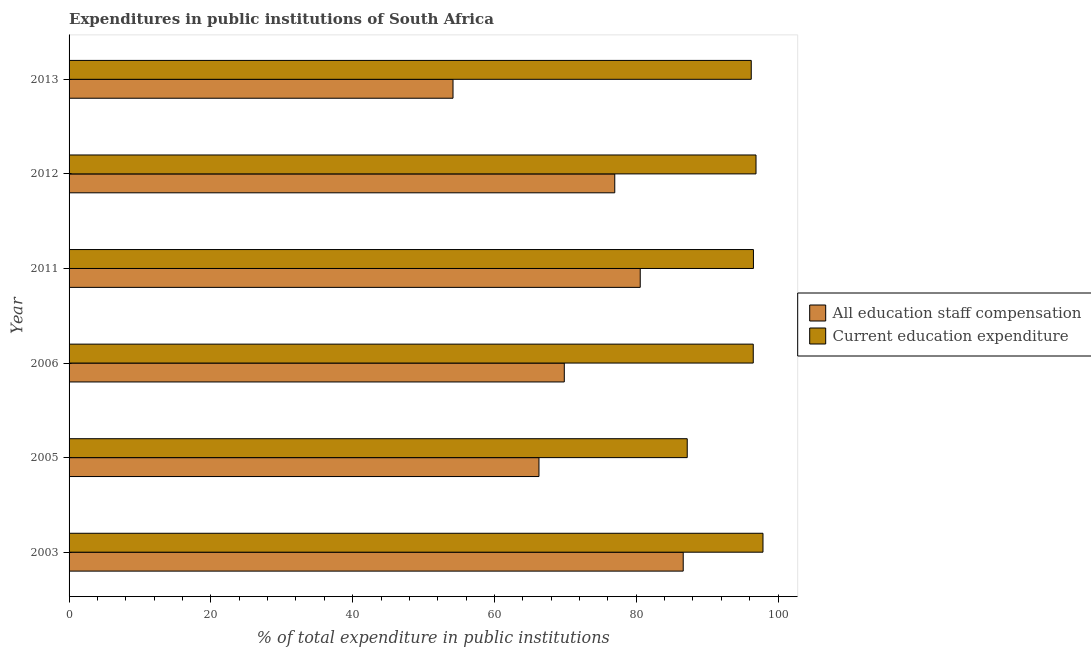How many groups of bars are there?
Ensure brevity in your answer.  6. What is the label of the 5th group of bars from the top?
Make the answer very short. 2005. In how many cases, is the number of bars for a given year not equal to the number of legend labels?
Ensure brevity in your answer.  0. What is the expenditure in staff compensation in 2012?
Ensure brevity in your answer.  76.97. Across all years, what is the maximum expenditure in education?
Offer a terse response. 97.87. Across all years, what is the minimum expenditure in staff compensation?
Provide a short and direct response. 54.15. In which year was the expenditure in staff compensation maximum?
Keep it short and to the point. 2003. In which year was the expenditure in staff compensation minimum?
Your answer should be very brief. 2013. What is the total expenditure in staff compensation in the graph?
Your answer should be compact. 434.42. What is the difference between the expenditure in staff compensation in 2005 and that in 2011?
Keep it short and to the point. -14.28. What is the difference between the expenditure in staff compensation in 2013 and the expenditure in education in 2006?
Make the answer very short. -42.35. What is the average expenditure in staff compensation per year?
Ensure brevity in your answer.  72.4. In the year 2011, what is the difference between the expenditure in education and expenditure in staff compensation?
Keep it short and to the point. 15.97. In how many years, is the expenditure in staff compensation greater than 16 %?
Keep it short and to the point. 6. What is the ratio of the expenditure in staff compensation in 2011 to that in 2012?
Give a very brief answer. 1.05. Is the expenditure in staff compensation in 2003 less than that in 2006?
Offer a very short reply. No. Is the difference between the expenditure in staff compensation in 2005 and 2012 greater than the difference between the expenditure in education in 2005 and 2012?
Provide a short and direct response. No. What is the difference between the highest and the lowest expenditure in staff compensation?
Provide a succinct answer. 32.47. In how many years, is the expenditure in education greater than the average expenditure in education taken over all years?
Keep it short and to the point. 5. Is the sum of the expenditure in education in 2005 and 2011 greater than the maximum expenditure in staff compensation across all years?
Offer a terse response. Yes. What does the 2nd bar from the top in 2006 represents?
Your answer should be compact. All education staff compensation. What does the 1st bar from the bottom in 2011 represents?
Your response must be concise. All education staff compensation. How many years are there in the graph?
Make the answer very short. 6. What is the difference between two consecutive major ticks on the X-axis?
Offer a very short reply. 20. Does the graph contain any zero values?
Your response must be concise. No. Does the graph contain grids?
Your answer should be very brief. No. Where does the legend appear in the graph?
Make the answer very short. Center right. How many legend labels are there?
Offer a very short reply. 2. How are the legend labels stacked?
Provide a succinct answer. Vertical. What is the title of the graph?
Offer a terse response. Expenditures in public institutions of South Africa. Does "Investment in Telecom" appear as one of the legend labels in the graph?
Offer a very short reply. No. What is the label or title of the X-axis?
Offer a terse response. % of total expenditure in public institutions. What is the label or title of the Y-axis?
Offer a very short reply. Year. What is the % of total expenditure in public institutions of All education staff compensation in 2003?
Provide a succinct answer. 86.62. What is the % of total expenditure in public institutions in Current education expenditure in 2003?
Ensure brevity in your answer.  97.87. What is the % of total expenditure in public institutions in All education staff compensation in 2005?
Your response must be concise. 66.28. What is the % of total expenditure in public institutions in Current education expenditure in 2005?
Ensure brevity in your answer.  87.19. What is the % of total expenditure in public institutions in All education staff compensation in 2006?
Offer a very short reply. 69.85. What is the % of total expenditure in public institutions in Current education expenditure in 2006?
Give a very brief answer. 96.5. What is the % of total expenditure in public institutions in All education staff compensation in 2011?
Give a very brief answer. 80.56. What is the % of total expenditure in public institutions in Current education expenditure in 2011?
Make the answer very short. 96.53. What is the % of total expenditure in public institutions in All education staff compensation in 2012?
Ensure brevity in your answer.  76.97. What is the % of total expenditure in public institutions in Current education expenditure in 2012?
Your answer should be very brief. 96.89. What is the % of total expenditure in public institutions of All education staff compensation in 2013?
Provide a succinct answer. 54.15. What is the % of total expenditure in public institutions in Current education expenditure in 2013?
Keep it short and to the point. 96.22. Across all years, what is the maximum % of total expenditure in public institutions in All education staff compensation?
Provide a succinct answer. 86.62. Across all years, what is the maximum % of total expenditure in public institutions in Current education expenditure?
Your response must be concise. 97.87. Across all years, what is the minimum % of total expenditure in public institutions in All education staff compensation?
Your answer should be compact. 54.15. Across all years, what is the minimum % of total expenditure in public institutions in Current education expenditure?
Your response must be concise. 87.19. What is the total % of total expenditure in public institutions of All education staff compensation in the graph?
Your answer should be very brief. 434.42. What is the total % of total expenditure in public institutions of Current education expenditure in the graph?
Offer a very short reply. 571.19. What is the difference between the % of total expenditure in public institutions in All education staff compensation in 2003 and that in 2005?
Provide a short and direct response. 20.35. What is the difference between the % of total expenditure in public institutions of Current education expenditure in 2003 and that in 2005?
Ensure brevity in your answer.  10.69. What is the difference between the % of total expenditure in public institutions of All education staff compensation in 2003 and that in 2006?
Ensure brevity in your answer.  16.77. What is the difference between the % of total expenditure in public institutions of Current education expenditure in 2003 and that in 2006?
Make the answer very short. 1.37. What is the difference between the % of total expenditure in public institutions in All education staff compensation in 2003 and that in 2011?
Provide a short and direct response. 6.06. What is the difference between the % of total expenditure in public institutions in Current education expenditure in 2003 and that in 2011?
Ensure brevity in your answer.  1.35. What is the difference between the % of total expenditure in public institutions in All education staff compensation in 2003 and that in 2012?
Give a very brief answer. 9.65. What is the difference between the % of total expenditure in public institutions of Current education expenditure in 2003 and that in 2012?
Provide a succinct answer. 0.98. What is the difference between the % of total expenditure in public institutions in All education staff compensation in 2003 and that in 2013?
Give a very brief answer. 32.47. What is the difference between the % of total expenditure in public institutions of Current education expenditure in 2003 and that in 2013?
Your answer should be very brief. 1.65. What is the difference between the % of total expenditure in public institutions in All education staff compensation in 2005 and that in 2006?
Your answer should be very brief. -3.57. What is the difference between the % of total expenditure in public institutions of Current education expenditure in 2005 and that in 2006?
Your response must be concise. -9.31. What is the difference between the % of total expenditure in public institutions of All education staff compensation in 2005 and that in 2011?
Your answer should be very brief. -14.28. What is the difference between the % of total expenditure in public institutions of Current education expenditure in 2005 and that in 2011?
Give a very brief answer. -9.34. What is the difference between the % of total expenditure in public institutions of All education staff compensation in 2005 and that in 2012?
Offer a very short reply. -10.69. What is the difference between the % of total expenditure in public institutions of Current education expenditure in 2005 and that in 2012?
Ensure brevity in your answer.  -9.7. What is the difference between the % of total expenditure in public institutions of All education staff compensation in 2005 and that in 2013?
Your answer should be compact. 12.12. What is the difference between the % of total expenditure in public institutions in Current education expenditure in 2005 and that in 2013?
Your answer should be very brief. -9.03. What is the difference between the % of total expenditure in public institutions of All education staff compensation in 2006 and that in 2011?
Keep it short and to the point. -10.71. What is the difference between the % of total expenditure in public institutions of Current education expenditure in 2006 and that in 2011?
Make the answer very short. -0.03. What is the difference between the % of total expenditure in public institutions in All education staff compensation in 2006 and that in 2012?
Your answer should be very brief. -7.12. What is the difference between the % of total expenditure in public institutions in Current education expenditure in 2006 and that in 2012?
Offer a very short reply. -0.39. What is the difference between the % of total expenditure in public institutions of All education staff compensation in 2006 and that in 2013?
Keep it short and to the point. 15.7. What is the difference between the % of total expenditure in public institutions of Current education expenditure in 2006 and that in 2013?
Offer a very short reply. 0.28. What is the difference between the % of total expenditure in public institutions of All education staff compensation in 2011 and that in 2012?
Provide a succinct answer. 3.59. What is the difference between the % of total expenditure in public institutions in Current education expenditure in 2011 and that in 2012?
Give a very brief answer. -0.36. What is the difference between the % of total expenditure in public institutions in All education staff compensation in 2011 and that in 2013?
Your response must be concise. 26.41. What is the difference between the % of total expenditure in public institutions in Current education expenditure in 2011 and that in 2013?
Provide a short and direct response. 0.31. What is the difference between the % of total expenditure in public institutions in All education staff compensation in 2012 and that in 2013?
Keep it short and to the point. 22.81. What is the difference between the % of total expenditure in public institutions of Current education expenditure in 2012 and that in 2013?
Offer a terse response. 0.67. What is the difference between the % of total expenditure in public institutions in All education staff compensation in 2003 and the % of total expenditure in public institutions in Current education expenditure in 2005?
Keep it short and to the point. -0.57. What is the difference between the % of total expenditure in public institutions of All education staff compensation in 2003 and the % of total expenditure in public institutions of Current education expenditure in 2006?
Your answer should be very brief. -9.88. What is the difference between the % of total expenditure in public institutions of All education staff compensation in 2003 and the % of total expenditure in public institutions of Current education expenditure in 2011?
Make the answer very short. -9.9. What is the difference between the % of total expenditure in public institutions in All education staff compensation in 2003 and the % of total expenditure in public institutions in Current education expenditure in 2012?
Make the answer very short. -10.27. What is the difference between the % of total expenditure in public institutions of All education staff compensation in 2003 and the % of total expenditure in public institutions of Current education expenditure in 2013?
Provide a succinct answer. -9.6. What is the difference between the % of total expenditure in public institutions in All education staff compensation in 2005 and the % of total expenditure in public institutions in Current education expenditure in 2006?
Your response must be concise. -30.22. What is the difference between the % of total expenditure in public institutions of All education staff compensation in 2005 and the % of total expenditure in public institutions of Current education expenditure in 2011?
Your answer should be very brief. -30.25. What is the difference between the % of total expenditure in public institutions of All education staff compensation in 2005 and the % of total expenditure in public institutions of Current education expenditure in 2012?
Provide a succinct answer. -30.61. What is the difference between the % of total expenditure in public institutions of All education staff compensation in 2005 and the % of total expenditure in public institutions of Current education expenditure in 2013?
Your answer should be very brief. -29.94. What is the difference between the % of total expenditure in public institutions in All education staff compensation in 2006 and the % of total expenditure in public institutions in Current education expenditure in 2011?
Your answer should be very brief. -26.68. What is the difference between the % of total expenditure in public institutions in All education staff compensation in 2006 and the % of total expenditure in public institutions in Current education expenditure in 2012?
Your answer should be compact. -27.04. What is the difference between the % of total expenditure in public institutions of All education staff compensation in 2006 and the % of total expenditure in public institutions of Current education expenditure in 2013?
Make the answer very short. -26.37. What is the difference between the % of total expenditure in public institutions of All education staff compensation in 2011 and the % of total expenditure in public institutions of Current education expenditure in 2012?
Your answer should be very brief. -16.33. What is the difference between the % of total expenditure in public institutions in All education staff compensation in 2011 and the % of total expenditure in public institutions in Current education expenditure in 2013?
Ensure brevity in your answer.  -15.66. What is the difference between the % of total expenditure in public institutions in All education staff compensation in 2012 and the % of total expenditure in public institutions in Current education expenditure in 2013?
Provide a succinct answer. -19.25. What is the average % of total expenditure in public institutions of All education staff compensation per year?
Your response must be concise. 72.4. What is the average % of total expenditure in public institutions of Current education expenditure per year?
Your response must be concise. 95.2. In the year 2003, what is the difference between the % of total expenditure in public institutions in All education staff compensation and % of total expenditure in public institutions in Current education expenditure?
Your response must be concise. -11.25. In the year 2005, what is the difference between the % of total expenditure in public institutions in All education staff compensation and % of total expenditure in public institutions in Current education expenditure?
Make the answer very short. -20.91. In the year 2006, what is the difference between the % of total expenditure in public institutions in All education staff compensation and % of total expenditure in public institutions in Current education expenditure?
Give a very brief answer. -26.65. In the year 2011, what is the difference between the % of total expenditure in public institutions of All education staff compensation and % of total expenditure in public institutions of Current education expenditure?
Offer a very short reply. -15.97. In the year 2012, what is the difference between the % of total expenditure in public institutions in All education staff compensation and % of total expenditure in public institutions in Current education expenditure?
Your response must be concise. -19.92. In the year 2013, what is the difference between the % of total expenditure in public institutions of All education staff compensation and % of total expenditure in public institutions of Current education expenditure?
Your answer should be very brief. -42.07. What is the ratio of the % of total expenditure in public institutions of All education staff compensation in 2003 to that in 2005?
Offer a very short reply. 1.31. What is the ratio of the % of total expenditure in public institutions of Current education expenditure in 2003 to that in 2005?
Offer a terse response. 1.12. What is the ratio of the % of total expenditure in public institutions of All education staff compensation in 2003 to that in 2006?
Your response must be concise. 1.24. What is the ratio of the % of total expenditure in public institutions of Current education expenditure in 2003 to that in 2006?
Give a very brief answer. 1.01. What is the ratio of the % of total expenditure in public institutions in All education staff compensation in 2003 to that in 2011?
Ensure brevity in your answer.  1.08. What is the ratio of the % of total expenditure in public institutions in All education staff compensation in 2003 to that in 2012?
Ensure brevity in your answer.  1.13. What is the ratio of the % of total expenditure in public institutions in Current education expenditure in 2003 to that in 2012?
Your answer should be very brief. 1.01. What is the ratio of the % of total expenditure in public institutions in All education staff compensation in 2003 to that in 2013?
Keep it short and to the point. 1.6. What is the ratio of the % of total expenditure in public institutions of Current education expenditure in 2003 to that in 2013?
Offer a terse response. 1.02. What is the ratio of the % of total expenditure in public institutions in All education staff compensation in 2005 to that in 2006?
Your answer should be compact. 0.95. What is the ratio of the % of total expenditure in public institutions in Current education expenditure in 2005 to that in 2006?
Provide a short and direct response. 0.9. What is the ratio of the % of total expenditure in public institutions of All education staff compensation in 2005 to that in 2011?
Provide a succinct answer. 0.82. What is the ratio of the % of total expenditure in public institutions of Current education expenditure in 2005 to that in 2011?
Make the answer very short. 0.9. What is the ratio of the % of total expenditure in public institutions of All education staff compensation in 2005 to that in 2012?
Offer a very short reply. 0.86. What is the ratio of the % of total expenditure in public institutions of Current education expenditure in 2005 to that in 2012?
Your answer should be very brief. 0.9. What is the ratio of the % of total expenditure in public institutions of All education staff compensation in 2005 to that in 2013?
Provide a short and direct response. 1.22. What is the ratio of the % of total expenditure in public institutions in Current education expenditure in 2005 to that in 2013?
Keep it short and to the point. 0.91. What is the ratio of the % of total expenditure in public institutions in All education staff compensation in 2006 to that in 2011?
Keep it short and to the point. 0.87. What is the ratio of the % of total expenditure in public institutions in All education staff compensation in 2006 to that in 2012?
Your response must be concise. 0.91. What is the ratio of the % of total expenditure in public institutions of All education staff compensation in 2006 to that in 2013?
Provide a short and direct response. 1.29. What is the ratio of the % of total expenditure in public institutions in Current education expenditure in 2006 to that in 2013?
Ensure brevity in your answer.  1. What is the ratio of the % of total expenditure in public institutions of All education staff compensation in 2011 to that in 2012?
Keep it short and to the point. 1.05. What is the ratio of the % of total expenditure in public institutions of Current education expenditure in 2011 to that in 2012?
Your response must be concise. 1. What is the ratio of the % of total expenditure in public institutions in All education staff compensation in 2011 to that in 2013?
Your answer should be very brief. 1.49. What is the ratio of the % of total expenditure in public institutions in Current education expenditure in 2011 to that in 2013?
Your answer should be compact. 1. What is the ratio of the % of total expenditure in public institutions of All education staff compensation in 2012 to that in 2013?
Give a very brief answer. 1.42. What is the ratio of the % of total expenditure in public institutions in Current education expenditure in 2012 to that in 2013?
Keep it short and to the point. 1.01. What is the difference between the highest and the second highest % of total expenditure in public institutions of All education staff compensation?
Keep it short and to the point. 6.06. What is the difference between the highest and the second highest % of total expenditure in public institutions of Current education expenditure?
Your answer should be very brief. 0.98. What is the difference between the highest and the lowest % of total expenditure in public institutions of All education staff compensation?
Offer a terse response. 32.47. What is the difference between the highest and the lowest % of total expenditure in public institutions in Current education expenditure?
Ensure brevity in your answer.  10.69. 